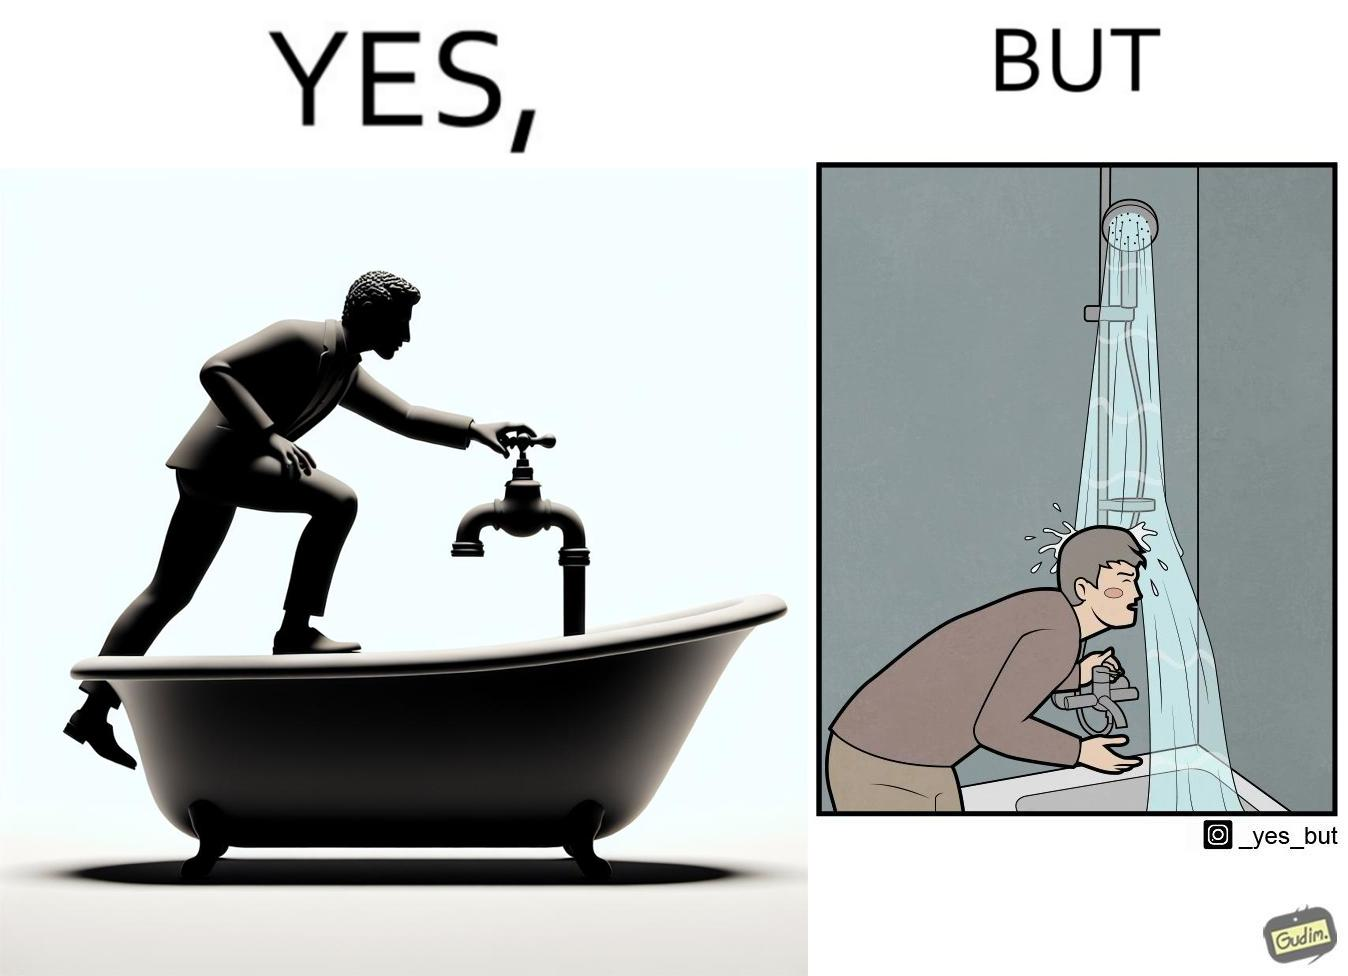Describe the content of this image. The image is funny, as the person is trying to operate the tap, but water comes out of the handheld shower resting on a holder instead of the tap, making the person drenched in water. 